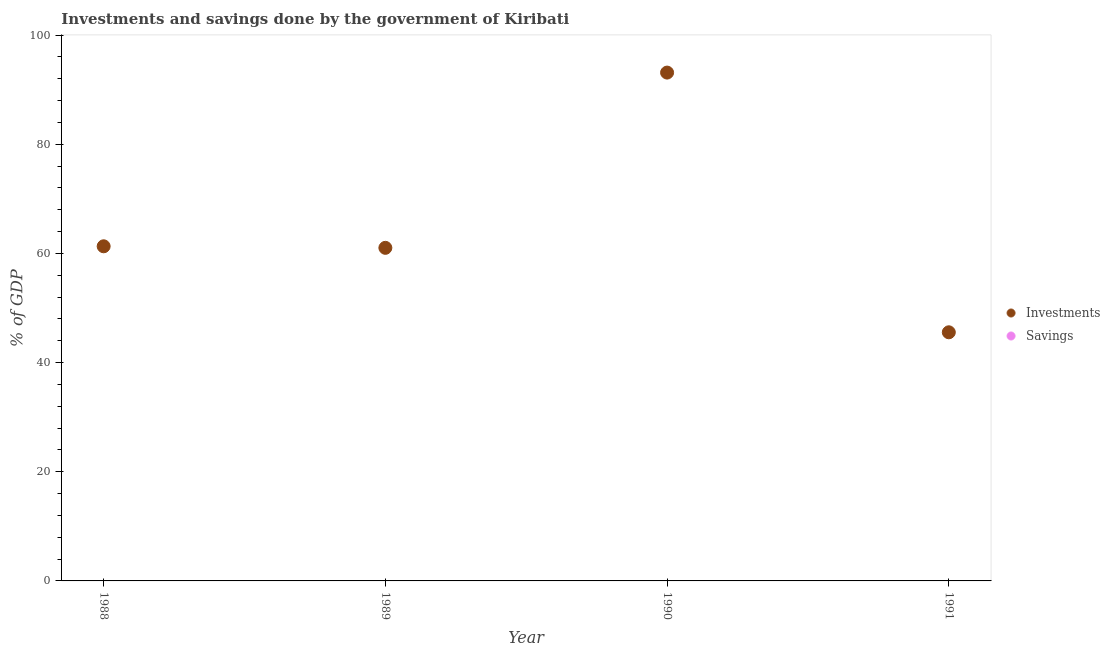How many different coloured dotlines are there?
Provide a succinct answer. 1. What is the investments of government in 1991?
Provide a short and direct response. 45.55. Across all years, what is the maximum investments of government?
Offer a terse response. 93.13. Across all years, what is the minimum savings of government?
Offer a very short reply. 0. In which year was the investments of government maximum?
Keep it short and to the point. 1990. What is the difference between the investments of government in 1988 and that in 1989?
Provide a succinct answer. 0.28. What is the difference between the savings of government in 1989 and the investments of government in 1988?
Offer a very short reply. -61.3. What is the average investments of government per year?
Your response must be concise. 65.25. In how many years, is the savings of government greater than 8 %?
Provide a succinct answer. 0. What is the ratio of the investments of government in 1988 to that in 1989?
Offer a terse response. 1. Is the investments of government in 1989 less than that in 1990?
Make the answer very short. Yes. What is the difference between the highest and the second highest investments of government?
Give a very brief answer. 31.82. What is the difference between the highest and the lowest investments of government?
Make the answer very short. 47.58. In how many years, is the savings of government greater than the average savings of government taken over all years?
Provide a short and direct response. 0. Does the savings of government monotonically increase over the years?
Give a very brief answer. No. How many dotlines are there?
Your answer should be compact. 1. What is the difference between two consecutive major ticks on the Y-axis?
Offer a very short reply. 20. Where does the legend appear in the graph?
Offer a terse response. Center right. How many legend labels are there?
Your response must be concise. 2. What is the title of the graph?
Make the answer very short. Investments and savings done by the government of Kiribati. What is the label or title of the Y-axis?
Your response must be concise. % of GDP. What is the % of GDP in Investments in 1988?
Keep it short and to the point. 61.3. What is the % of GDP in Savings in 1988?
Your answer should be compact. 0. What is the % of GDP of Investments in 1989?
Give a very brief answer. 61.02. What is the % of GDP in Savings in 1989?
Provide a succinct answer. 0. What is the % of GDP in Investments in 1990?
Make the answer very short. 93.13. What is the % of GDP in Investments in 1991?
Provide a succinct answer. 45.55. Across all years, what is the maximum % of GDP of Investments?
Offer a very short reply. 93.13. Across all years, what is the minimum % of GDP of Investments?
Ensure brevity in your answer.  45.55. What is the total % of GDP of Investments in the graph?
Keep it short and to the point. 261.01. What is the total % of GDP in Savings in the graph?
Provide a short and direct response. 0. What is the difference between the % of GDP in Investments in 1988 and that in 1989?
Keep it short and to the point. 0.28. What is the difference between the % of GDP of Investments in 1988 and that in 1990?
Provide a short and direct response. -31.82. What is the difference between the % of GDP in Investments in 1988 and that in 1991?
Provide a succinct answer. 15.76. What is the difference between the % of GDP of Investments in 1989 and that in 1990?
Ensure brevity in your answer.  -32.11. What is the difference between the % of GDP in Investments in 1989 and that in 1991?
Your answer should be very brief. 15.47. What is the difference between the % of GDP in Investments in 1990 and that in 1991?
Ensure brevity in your answer.  47.58. What is the average % of GDP in Investments per year?
Your answer should be compact. 65.25. What is the ratio of the % of GDP of Investments in 1988 to that in 1989?
Offer a terse response. 1. What is the ratio of the % of GDP in Investments in 1988 to that in 1990?
Your answer should be compact. 0.66. What is the ratio of the % of GDP of Investments in 1988 to that in 1991?
Provide a succinct answer. 1.35. What is the ratio of the % of GDP of Investments in 1989 to that in 1990?
Offer a very short reply. 0.66. What is the ratio of the % of GDP of Investments in 1989 to that in 1991?
Your answer should be compact. 1.34. What is the ratio of the % of GDP of Investments in 1990 to that in 1991?
Provide a short and direct response. 2.04. What is the difference between the highest and the second highest % of GDP of Investments?
Offer a very short reply. 31.82. What is the difference between the highest and the lowest % of GDP in Investments?
Offer a terse response. 47.58. 